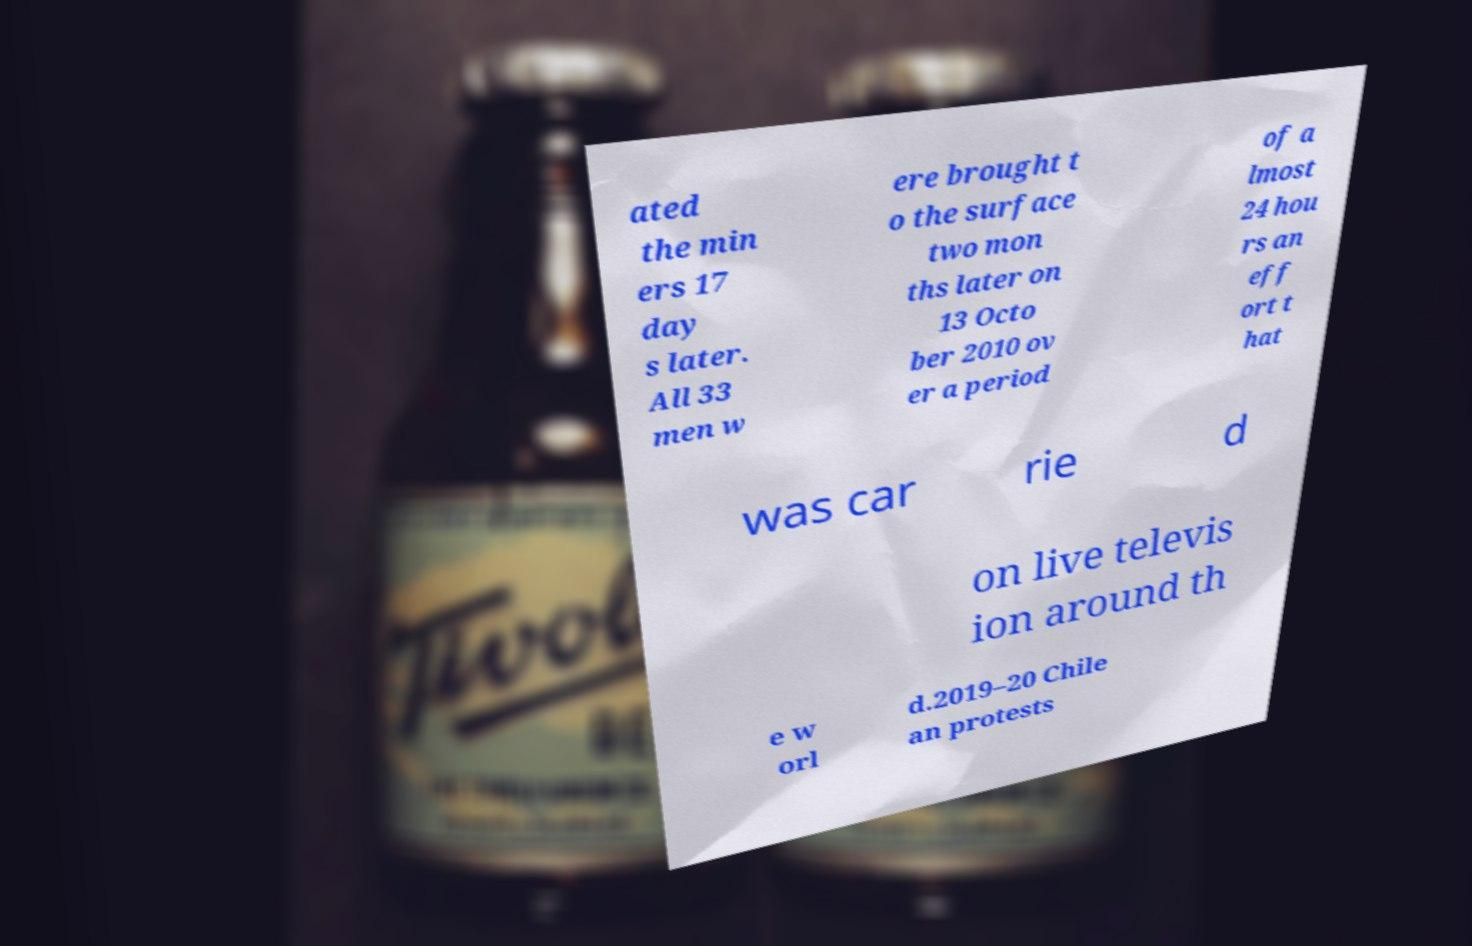Could you assist in decoding the text presented in this image and type it out clearly? ated the min ers 17 day s later. All 33 men w ere brought t o the surface two mon ths later on 13 Octo ber 2010 ov er a period of a lmost 24 hou rs an eff ort t hat was car rie d on live televis ion around th e w orl d.2019–20 Chile an protests 